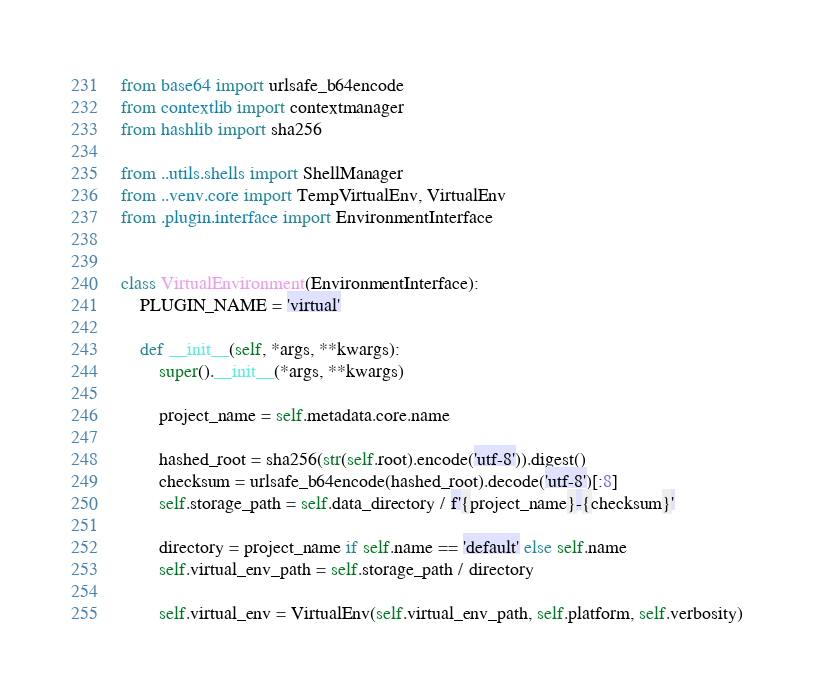Convert code to text. <code><loc_0><loc_0><loc_500><loc_500><_Python_>from base64 import urlsafe_b64encode
from contextlib import contextmanager
from hashlib import sha256

from ..utils.shells import ShellManager
from ..venv.core import TempVirtualEnv, VirtualEnv
from .plugin.interface import EnvironmentInterface


class VirtualEnvironment(EnvironmentInterface):
    PLUGIN_NAME = 'virtual'

    def __init__(self, *args, **kwargs):
        super().__init__(*args, **kwargs)

        project_name = self.metadata.core.name

        hashed_root = sha256(str(self.root).encode('utf-8')).digest()
        checksum = urlsafe_b64encode(hashed_root).decode('utf-8')[:8]
        self.storage_path = self.data_directory / f'{project_name}-{checksum}'

        directory = project_name if self.name == 'default' else self.name
        self.virtual_env_path = self.storage_path / directory

        self.virtual_env = VirtualEnv(self.virtual_env_path, self.platform, self.verbosity)</code> 